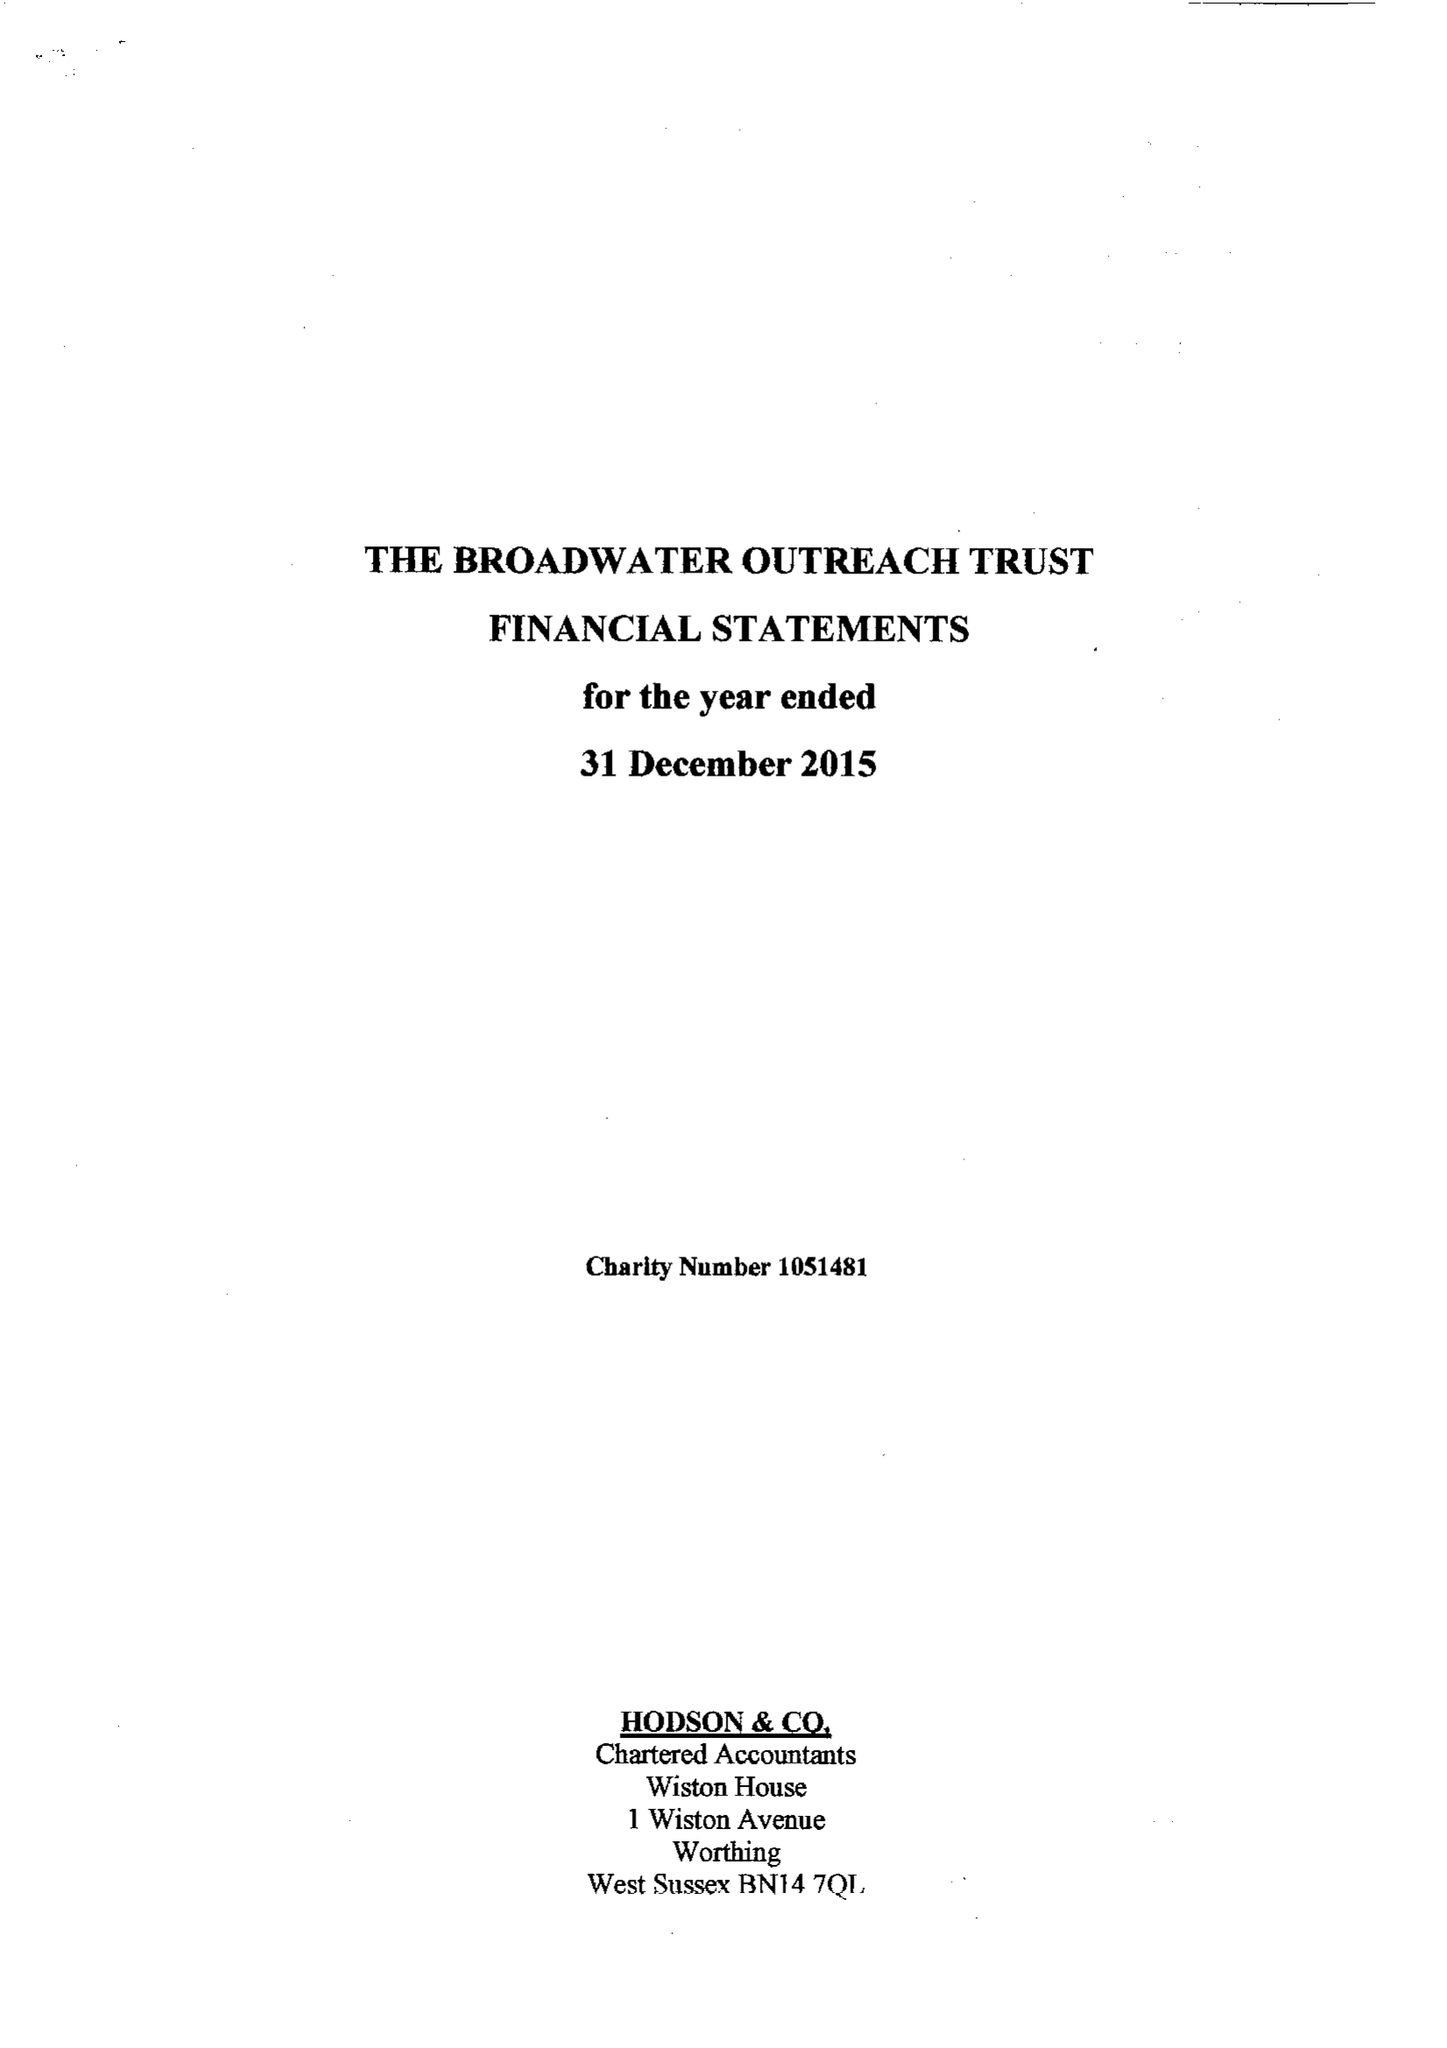What is the value for the address__post_town?
Answer the question using a single word or phrase. WORTHING 